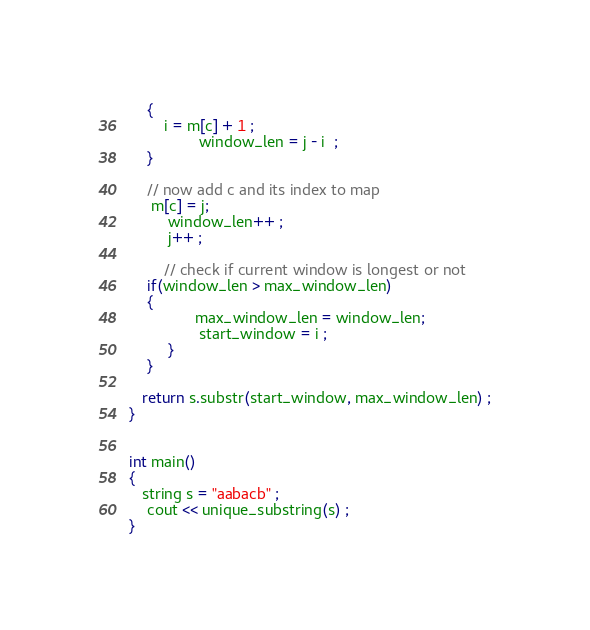Convert code to text. <code><loc_0><loc_0><loc_500><loc_500><_C++_>	{
		i = m[c] + 1 ;
                window_len = j - i  ;
	}
			
	// now add c and its index to map
	 m[c] = j;
         window_len++ ;
         j++ ;

        // check if current window is longest or not
	if(window_len > max_window_len)
	{
               max_window_len = window_len; 
                start_window = i ;
         }
    }

   return s.substr(start_window, max_window_len) ;
}
	

int main()
{
   string s = "aabacb" ;
    cout << unique_substring(s) ;		
}
</code> 